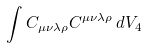<formula> <loc_0><loc_0><loc_500><loc_500>\int C _ { \mu \nu \lambda \rho } C ^ { \mu \nu \lambda \rho } \, d V _ { 4 }</formula> 